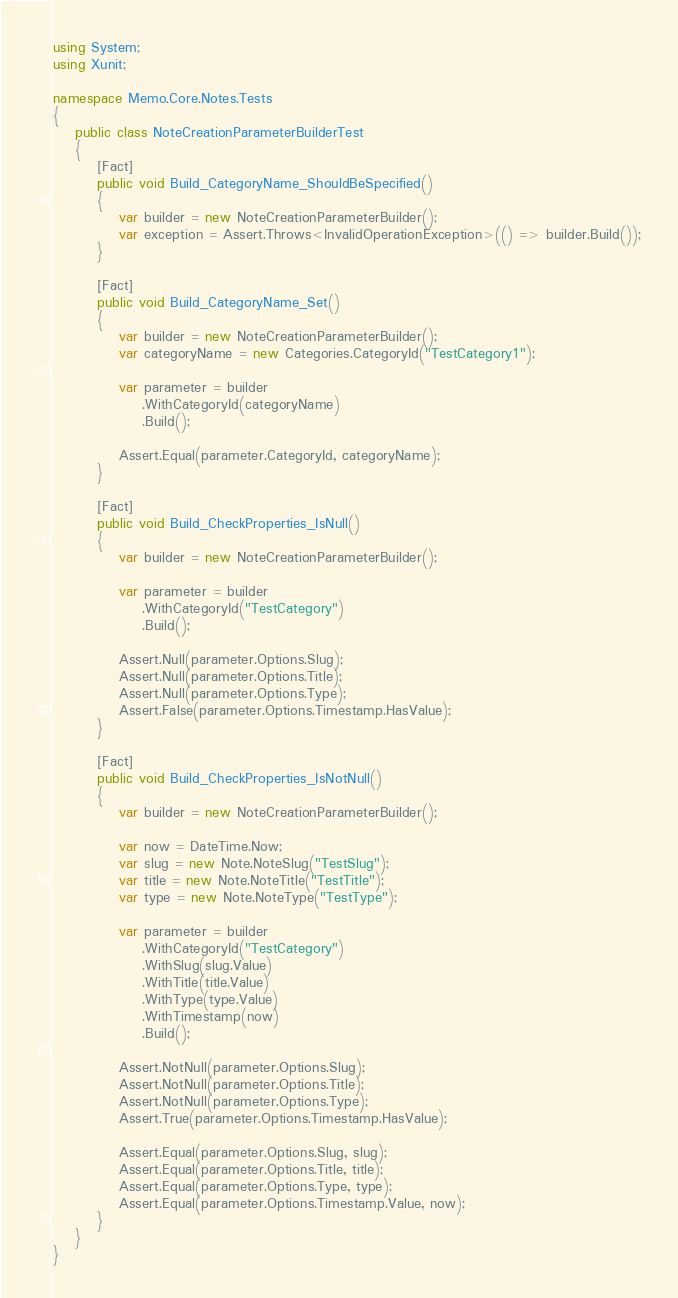Convert code to text. <code><loc_0><loc_0><loc_500><loc_500><_C#_>using System;
using Xunit;

namespace Memo.Core.Notes.Tests
{
    public class NoteCreationParameterBuilderTest
    {
        [Fact]
        public void Build_CategoryName_ShouldBeSpecified()
        {
            var builder = new NoteCreationParameterBuilder();
            var exception = Assert.Throws<InvalidOperationException>(() => builder.Build());
        }

        [Fact]
        public void Build_CategoryName_Set()
        {
            var builder = new NoteCreationParameterBuilder();
            var categoryName = new Categories.CategoryId("TestCategory1");

            var parameter = builder
                .WithCategoryId(categoryName)
                .Build();

            Assert.Equal(parameter.CategoryId, categoryName);
        }

        [Fact]
        public void Build_CheckProperties_IsNull()
        {
            var builder = new NoteCreationParameterBuilder();

            var parameter = builder
                .WithCategoryId("TestCategory")
                .Build();

            Assert.Null(parameter.Options.Slug);
            Assert.Null(parameter.Options.Title);
            Assert.Null(parameter.Options.Type);
            Assert.False(parameter.Options.Timestamp.HasValue);
        }

        [Fact]
        public void Build_CheckProperties_IsNotNull()
        {
            var builder = new NoteCreationParameterBuilder();

            var now = DateTime.Now;
            var slug = new Note.NoteSlug("TestSlug");
            var title = new Note.NoteTitle("TestTitle");
            var type = new Note.NoteType("TestType");

            var parameter = builder
                .WithCategoryId("TestCategory")
                .WithSlug(slug.Value)
                .WithTitle(title.Value)
                .WithType(type.Value)
                .WithTimestamp(now)
                .Build();

            Assert.NotNull(parameter.Options.Slug);
            Assert.NotNull(parameter.Options.Title);
            Assert.NotNull(parameter.Options.Type);
            Assert.True(parameter.Options.Timestamp.HasValue);            

            Assert.Equal(parameter.Options.Slug, slug);
            Assert.Equal(parameter.Options.Title, title);
            Assert.Equal(parameter.Options.Type, type);
            Assert.Equal(parameter.Options.Timestamp.Value, now);
        }
    }
}
</code> 